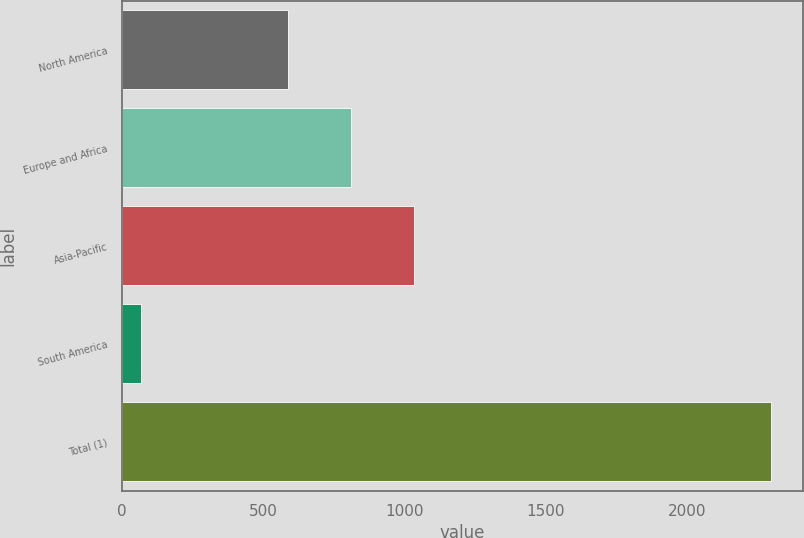Convert chart. <chart><loc_0><loc_0><loc_500><loc_500><bar_chart><fcel>North America<fcel>Europe and Africa<fcel>Asia-Pacific<fcel>South America<fcel>Total (1)<nl><fcel>588<fcel>811.1<fcel>1034.2<fcel>66<fcel>2297<nl></chart> 